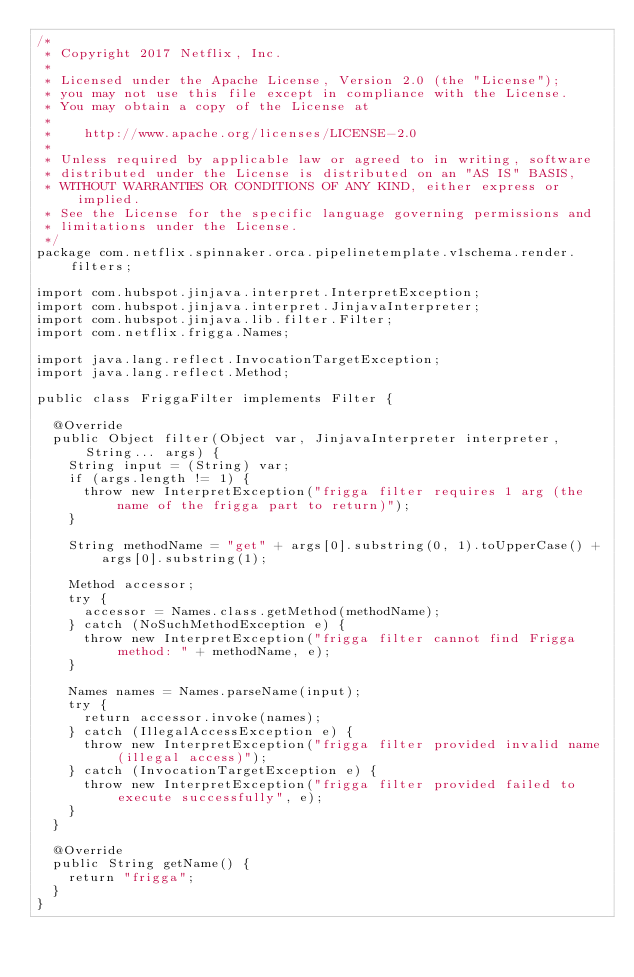<code> <loc_0><loc_0><loc_500><loc_500><_Java_>/*
 * Copyright 2017 Netflix, Inc.
 *
 * Licensed under the Apache License, Version 2.0 (the "License");
 * you may not use this file except in compliance with the License.
 * You may obtain a copy of the License at
 *
 *    http://www.apache.org/licenses/LICENSE-2.0
 *
 * Unless required by applicable law or agreed to in writing, software
 * distributed under the License is distributed on an "AS IS" BASIS,
 * WITHOUT WARRANTIES OR CONDITIONS OF ANY KIND, either express or implied.
 * See the License for the specific language governing permissions and
 * limitations under the License.
 */
package com.netflix.spinnaker.orca.pipelinetemplate.v1schema.render.filters;

import com.hubspot.jinjava.interpret.InterpretException;
import com.hubspot.jinjava.interpret.JinjavaInterpreter;
import com.hubspot.jinjava.lib.filter.Filter;
import com.netflix.frigga.Names;

import java.lang.reflect.InvocationTargetException;
import java.lang.reflect.Method;

public class FriggaFilter implements Filter {

  @Override
  public Object filter(Object var, JinjavaInterpreter interpreter, String... args) {
    String input = (String) var;
    if (args.length != 1) {
      throw new InterpretException("frigga filter requires 1 arg (the name of the frigga part to return)");
    }

    String methodName = "get" + args[0].substring(0, 1).toUpperCase() + args[0].substring(1);

    Method accessor;
    try {
      accessor = Names.class.getMethod(methodName);
    } catch (NoSuchMethodException e) {
      throw new InterpretException("frigga filter cannot find Frigga method: " + methodName, e);
    }

    Names names = Names.parseName(input);
    try {
      return accessor.invoke(names);
    } catch (IllegalAccessException e) {
      throw new InterpretException("frigga filter provided invalid name (illegal access)");
    } catch (InvocationTargetException e) {
      throw new InterpretException("frigga filter provided failed to execute successfully", e);
    }
  }

  @Override
  public String getName() {
    return "frigga";
  }
}
</code> 